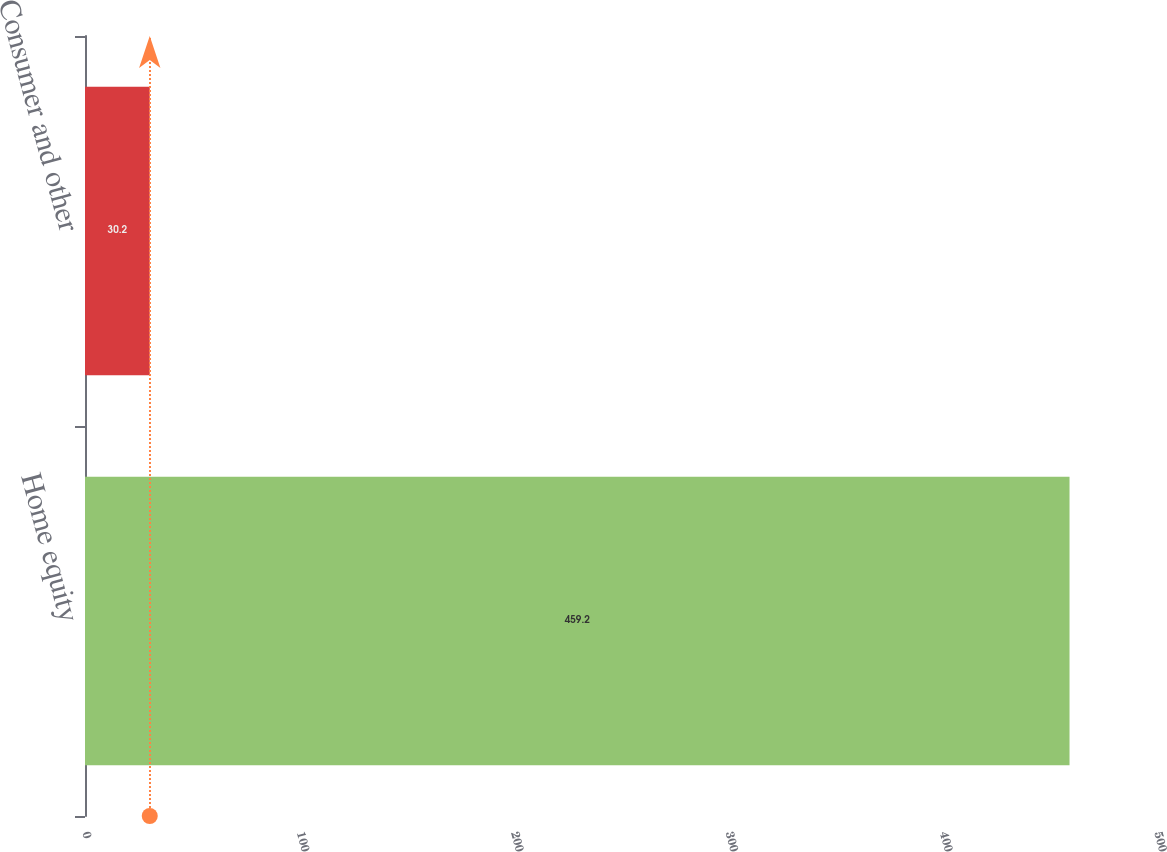Convert chart. <chart><loc_0><loc_0><loc_500><loc_500><bar_chart><fcel>Home equity<fcel>Consumer and other<nl><fcel>459.2<fcel>30.2<nl></chart> 